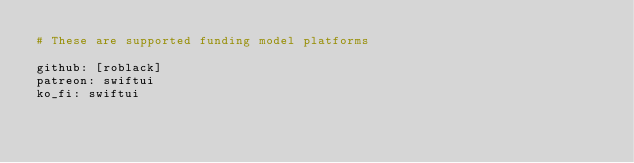<code> <loc_0><loc_0><loc_500><loc_500><_YAML_># These are supported funding model platforms

github: [roblack]
patreon: swiftui
ko_fi: swiftui
</code> 